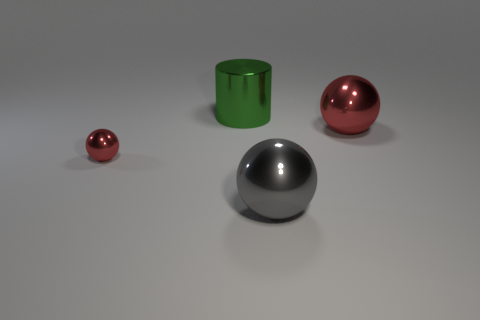Do the ball that is behind the small shiny sphere and the small metallic ball have the same color?
Provide a short and direct response. Yes. What is the size of the other red metal object that is the same shape as the small object?
Make the answer very short. Large. There is a large thing behind the red shiny sphere behind the red metal object that is on the left side of the big green shiny cylinder; what is its color?
Offer a terse response. Green. Do the large cylinder and the gray ball have the same material?
Offer a terse response. Yes. There is a big green shiny object behind the red ball to the left of the green shiny thing; is there a red shiny sphere that is on the left side of it?
Your answer should be compact. Yes. Is the number of large things less than the number of gray things?
Offer a terse response. No. Are the ball that is behind the tiny red thing and the ball left of the cylinder made of the same material?
Your response must be concise. Yes. Are there fewer large cylinders that are left of the green thing than large blue shiny objects?
Keep it short and to the point. No. How many large spheres are in front of the big metal sphere behind the small red metallic thing?
Your response must be concise. 1. There is a object that is both right of the large green shiny cylinder and in front of the large red sphere; what is its size?
Provide a succinct answer. Large. 